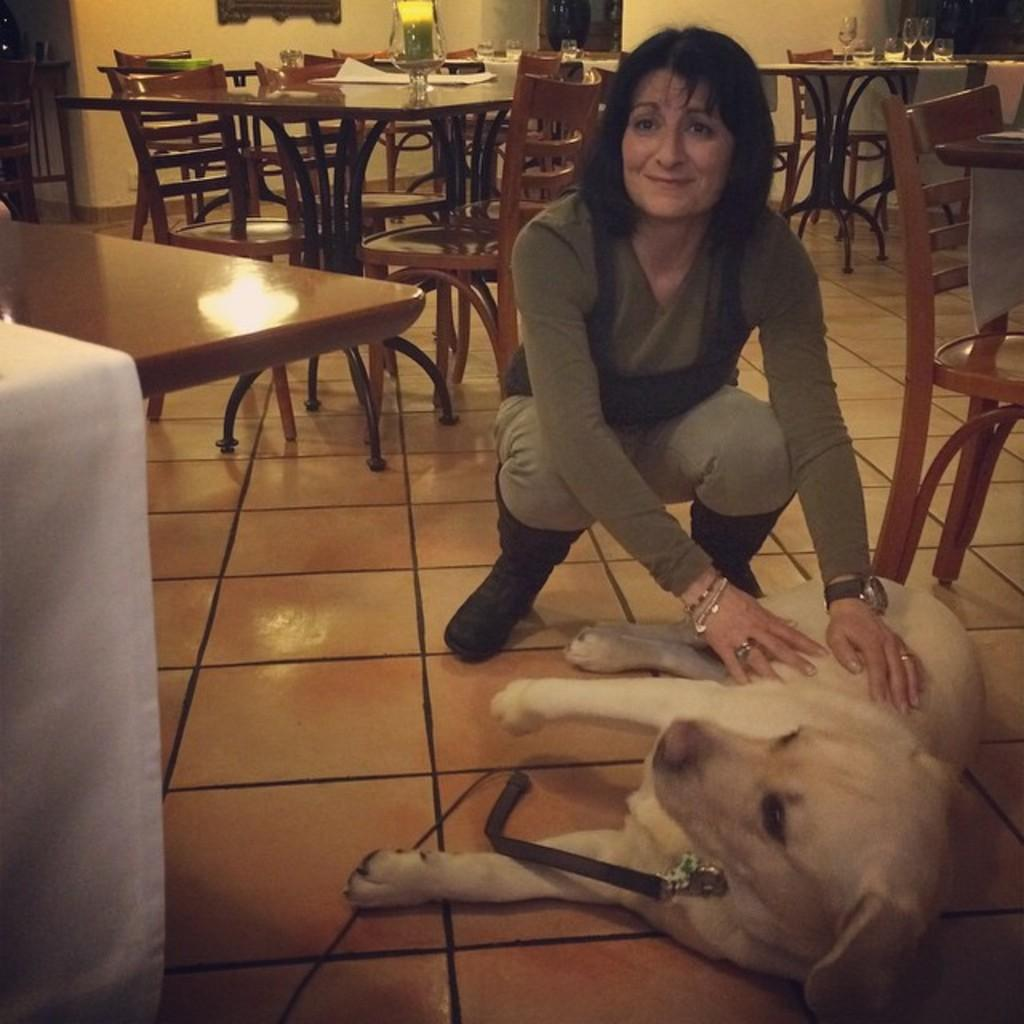Who is present in the room in the image? There is a woman in the room. What is the woman doing in the image? The woman is playing with a dog. How is the woman interacting with the dog? The woman is placing her hands on the dog. Where is the dog located in the image? The dog is on the floor. What type of furniture can be seen in the background of the room? There are chairs and tables in the background of the room. What type of hook is the woman using to catch the current in the image? There is no hook or current present in the image; it features a woman playing with a dog on the floor. At what angle is the dog positioned in the image? The dog's position cannot be described in terms of angles, as it is simply lying on the floor. 